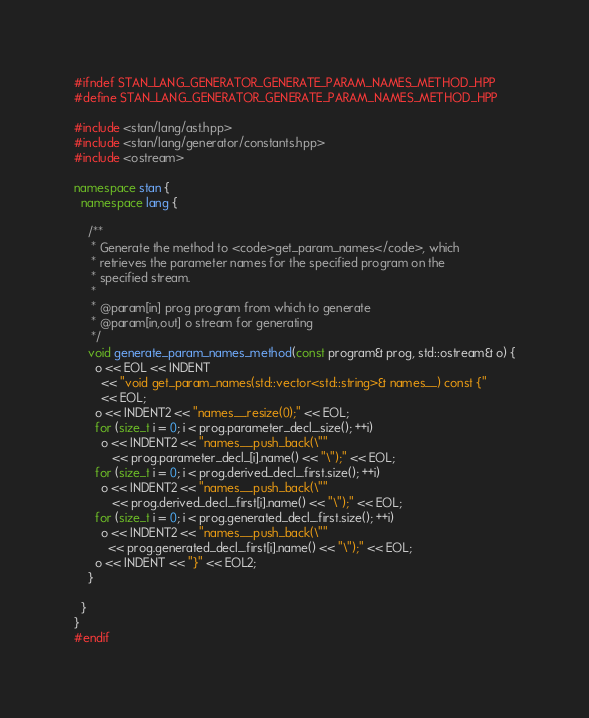Convert code to text. <code><loc_0><loc_0><loc_500><loc_500><_C++_>#ifndef STAN_LANG_GENERATOR_GENERATE_PARAM_NAMES_METHOD_HPP
#define STAN_LANG_GENERATOR_GENERATE_PARAM_NAMES_METHOD_HPP

#include <stan/lang/ast.hpp>
#include <stan/lang/generator/constants.hpp>
#include <ostream>

namespace stan {
  namespace lang {

    /**
     * Generate the method to <code>get_param_names</code>, which
     * retrieves the parameter names for the specified program on the
     * specified stream.
     *
     * @param[in] prog program from which to generate
     * @param[in,out] o stream for generating
     */
    void generate_param_names_method(const program& prog, std::ostream& o) {
      o << EOL << INDENT
        << "void get_param_names(std::vector<std::string>& names__) const {"
        << EOL;
      o << INDENT2 << "names__.resize(0);" << EOL;
      for (size_t i = 0; i < prog.parameter_decl_.size(); ++i)
        o << INDENT2 << "names__.push_back(\""
           << prog.parameter_decl_[i].name() << "\");" << EOL;
      for (size_t i = 0; i < prog.derived_decl_.first.size(); ++i)
        o << INDENT2 << "names__.push_back(\""
           << prog.derived_decl_.first[i].name() << "\");" << EOL;
      for (size_t i = 0; i < prog.generated_decl_.first.size(); ++i)
        o << INDENT2 << "names__.push_back(\""
          << prog.generated_decl_.first[i].name() << "\");" << EOL;
      o << INDENT << "}" << EOL2;
    }

  }
}
#endif
</code> 